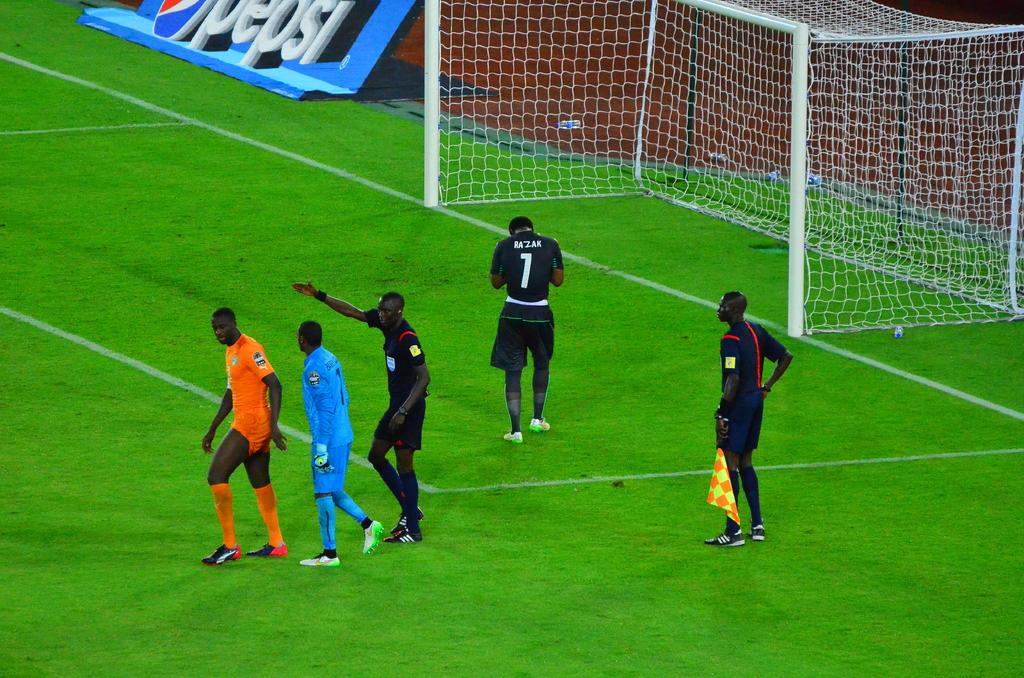<image>
Create a compact narrative representing the image presented. a player on a field with the number 7 on it 